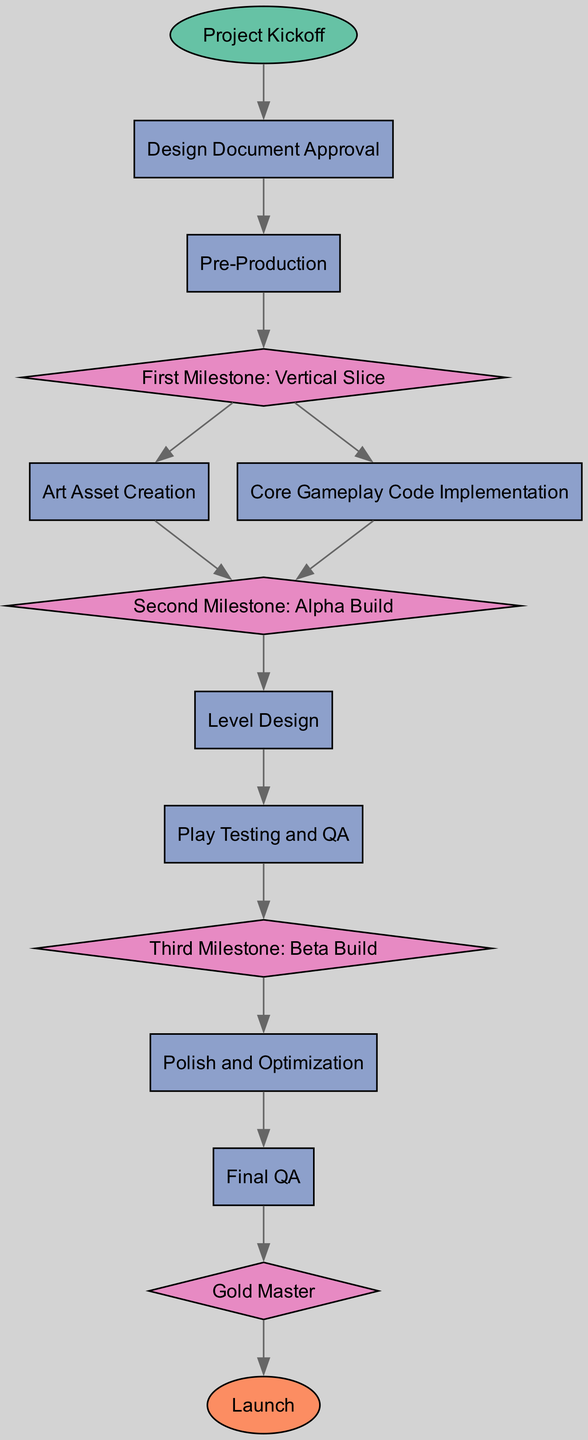What is the first activity after the project kickoff? The diagram shows that after the Project Kickoff, the next activity is Design Document Approval, as indicated by the directed edge from "kickoff" to "design_doc".
Answer: Design Document Approval How many milestones are present in the diagram? The diagram contains a total of four milestones: First Milestone: Vertical Slice, Second Milestone: Alpha Build, Third Milestone: Beta Build, and Gold Master. Counting these gives four distinct milestones.
Answer: 4 Which activity follows the Second Milestone? The diagram indicates that after the Second Milestone: Alpha Build, the next activity is Level Design, as shown by the directed edge from "milestone2" to "level_design".
Answer: Level Design What activity comes before Final QA? According to the diagram, the activity that precedes Final QA is Polish and Optimization, as indicated by the edge from "polish" to "final_qa".
Answer: Polish and Optimization What is the final milestone before the game launch? The diagram indicates that the final milestone before the Launch is Gold Master. This is shown by the directed edge from "milestone4" to "release".
Answer: Gold Master After which activity do you conduct Play Testing and QA? The diagram shows that Play Testing and QA occurs after Level Design, as indicated by the directed edge connecting "level_design" to "play_test".
Answer: Level Design Which node type is used to represent the Project Kickoff in the diagram? In the diagram, the Project Kickoff is represented as a start node, which is typically depicted in an oval shape, as seen from its node type in the data.
Answer: start What is the total number of activities in the diagram? There are six activities: Design Document Approval, Pre-Production, Art Asset Creation, Core Gameplay Code Implementation, Level Design, and Play Testing and QA, leading to a total of six activities in the diagram.
Answer: 6 